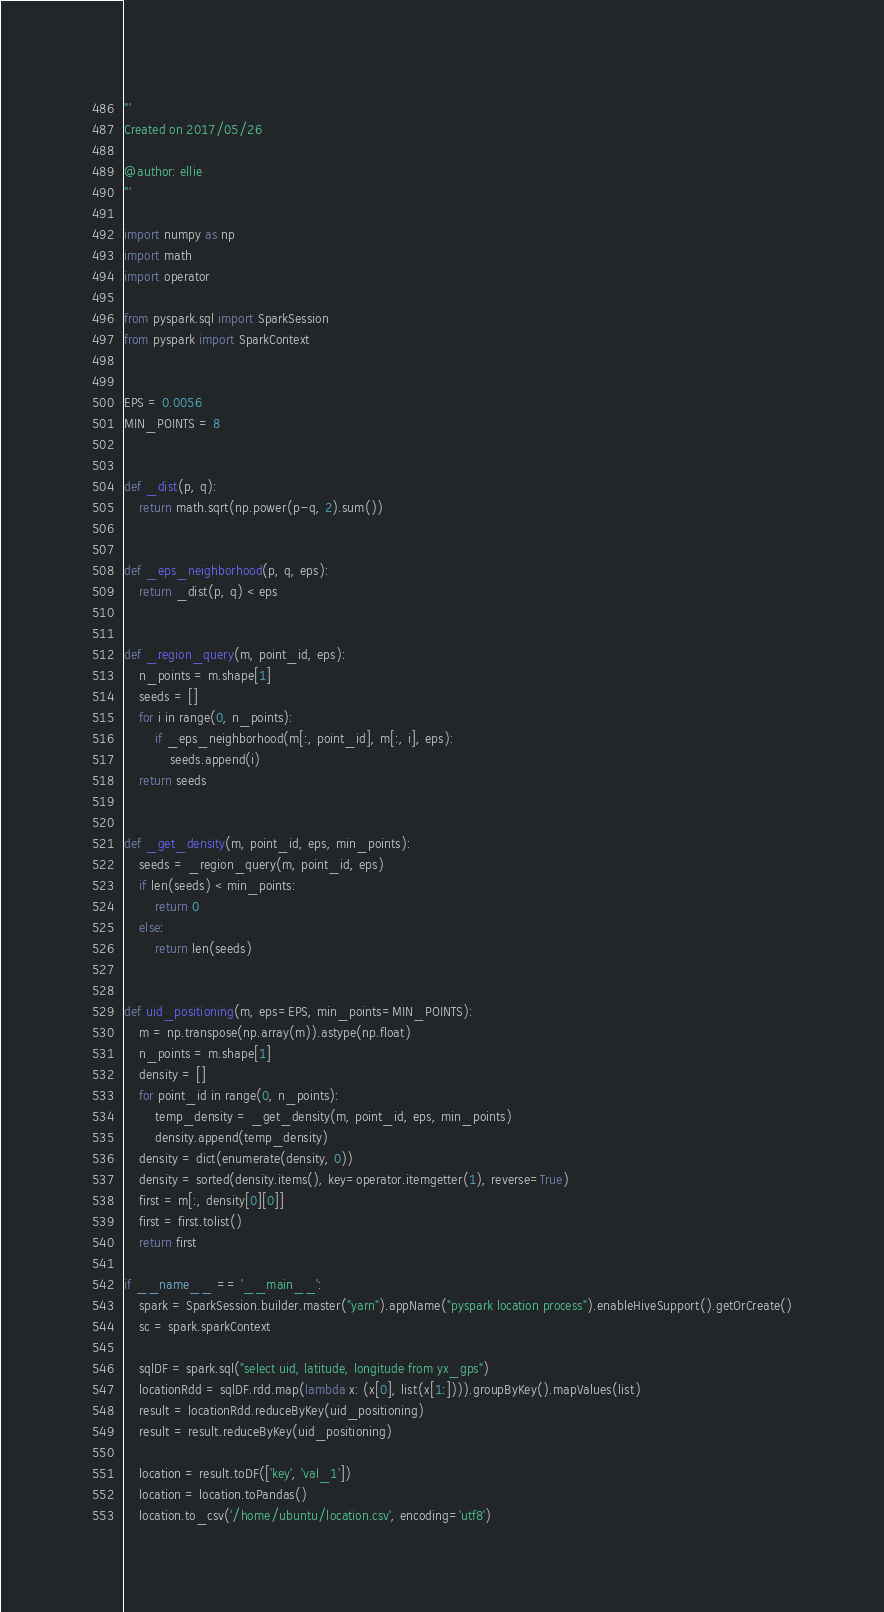<code> <loc_0><loc_0><loc_500><loc_500><_Python_>'''
Created on 2017/05/26

@author: ellie
'''

import numpy as np
import math
import operator

from pyspark.sql import SparkSession
from pyspark import SparkContext


EPS = 0.0056
MIN_POINTS = 8


def _dist(p, q):
    return math.sqrt(np.power(p-q, 2).sum())


def _eps_neighborhood(p, q, eps):
    return _dist(p, q) < eps


def _region_query(m, point_id, eps):
    n_points = m.shape[1]
    seeds = []
    for i in range(0, n_points):
        if _eps_neighborhood(m[:, point_id], m[:, i], eps):
            seeds.append(i)
    return seeds


def _get_density(m, point_id, eps, min_points):
    seeds = _region_query(m, point_id, eps)
    if len(seeds) < min_points:
        return 0
    else:
        return len(seeds)


def uid_positioning(m, eps=EPS, min_points=MIN_POINTS):
    m = np.transpose(np.array(m)).astype(np.float)
    n_points = m.shape[1]
    density = []
    for point_id in range(0, n_points):
        temp_density = _get_density(m, point_id, eps, min_points)
        density.append(temp_density)
    density = dict(enumerate(density, 0))
    density = sorted(density.items(), key=operator.itemgetter(1), reverse=True)
    first = m[:, density[0][0]]
    first = first.tolist()
    return first

if __name__ == '__main__':
    spark = SparkSession.builder.master("yarn").appName("pyspark location process").enableHiveSupport().getOrCreate()
    sc = spark.sparkContext

    sqlDF = spark.sql("select uid, latitude, longitude from yx_gps")
    locationRdd = sqlDF.rdd.map(lambda x: (x[0], list(x[1:]))).groupByKey().mapValues(list)
    result = locationRdd.reduceByKey(uid_positioning)
    result = result.reduceByKey(uid_positioning)

    location = result.toDF(['key', 'val_1'])
    location = location.toPandas()
    location.to_csv('/home/ubuntu/location.csv', encoding='utf8')

</code> 